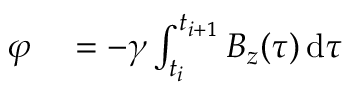<formula> <loc_0><loc_0><loc_500><loc_500>\begin{array} { r l } { \varphi } & = - \gamma \int _ { t _ { i } } ^ { t _ { i + 1 } } B _ { z } ( \tau ) \, d \tau } \end{array}</formula> 